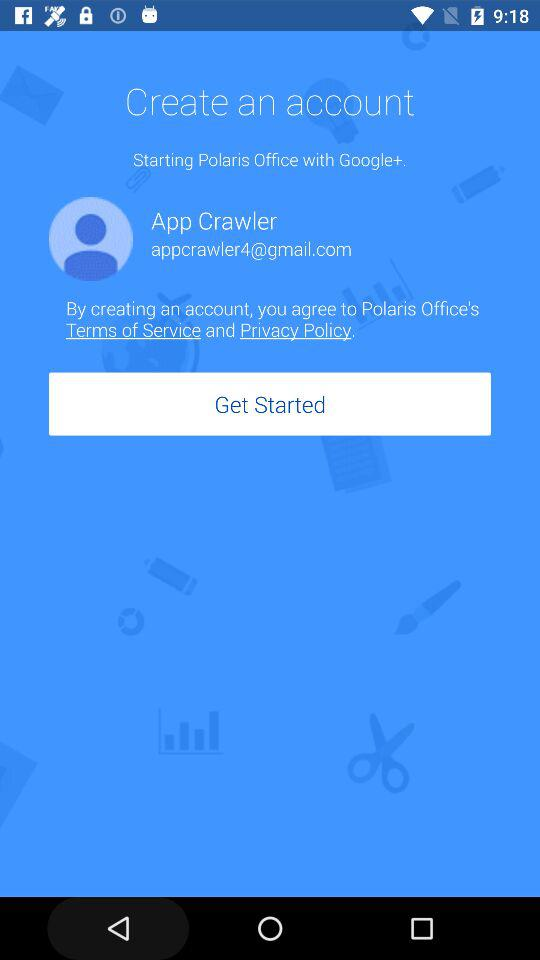What is the name of the user? The user name is "App Crawler". 